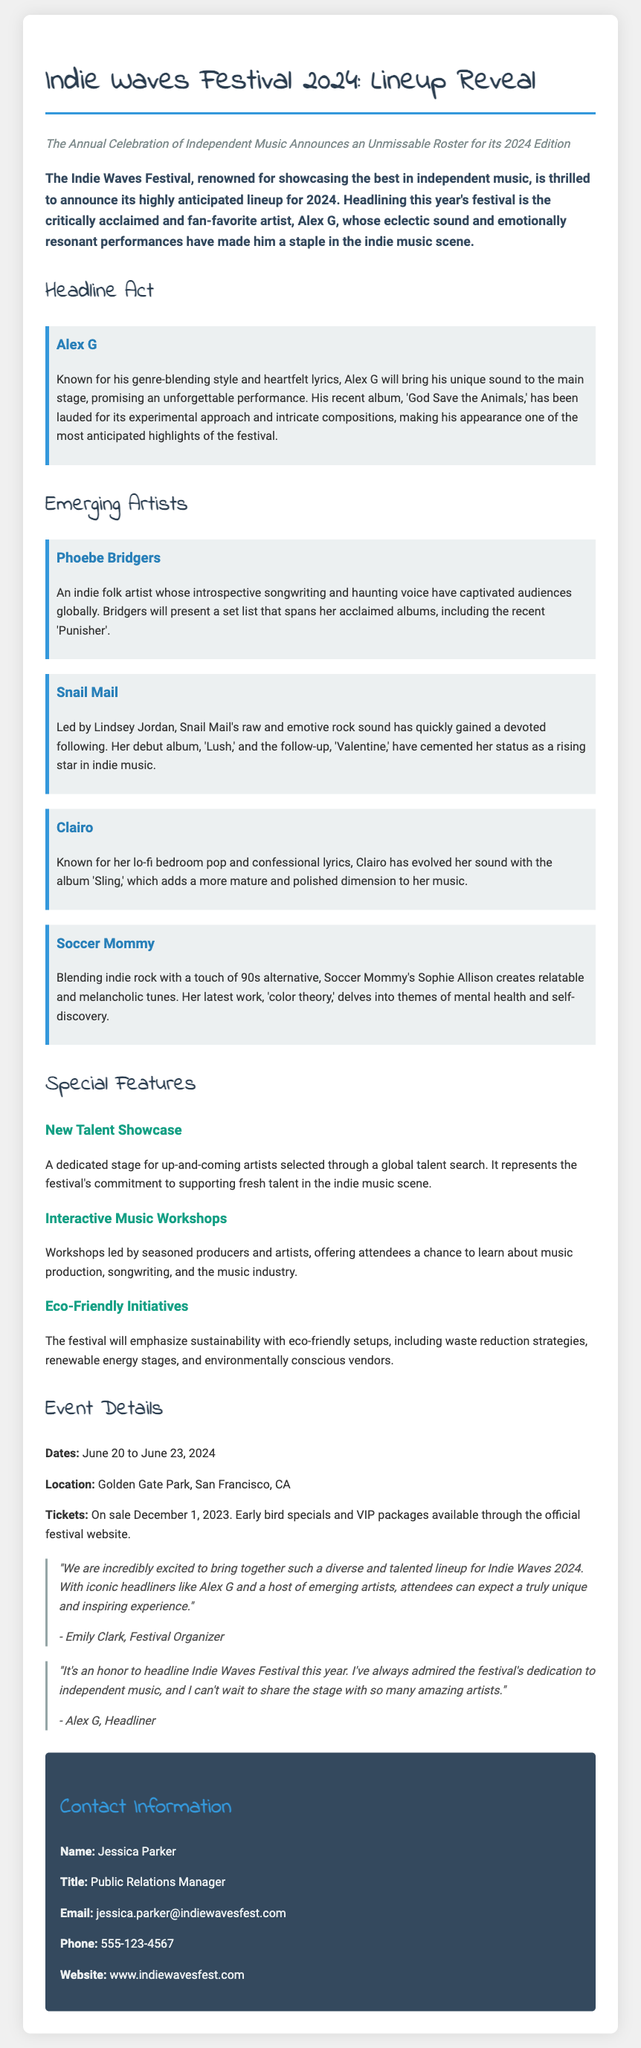What are the festival dates? The festival dates are mentioned in the event details section of the document, which states that it will take place from June 20 to June 23, 2024.
Answer: June 20 to June 23, 2024 Who is the headliner for the festival? The lead section of the press release specifies that Alex G is the headliner for this year's festival.
Answer: Alex G Where is the Indie Waves Festival held? The location is provided in the event details section, which states that it will be held at Golden Gate Park, San Francisco, CA.
Answer: Golden Gate Park, San Francisco, CA What is one of the special features of the festival? The special features of the festival include several aspects such as interactive music workshops, which are mentioned in the special features section of the document.
Answer: Interactive Music Workshops When can tickets be purchased? The document specifies that tickets will be on sale starting December 1, 2023.
Answer: December 1, 2023 What type of artists will be showcased besides the headliner? The document mentions that emerging artists will also be showcased alongside the headliner.
Answer: Emerging Artists What does the New Talent Showcase emphasize? The New Talent Showcase, as described in the special features section, emphasizes the festival's commitment to supporting fresh talent.
Answer: Supporting fresh talent Who is the Public Relations Manager for the festival? The contact information section lists Jessica Parker as the Public Relations Manager for the festival.
Answer: Jessica Parker What is the focus of the eco-friendly initiatives mentioned? The eco-friendly initiatives section highlights an emphasis on sustainability in the festival's operations.
Answer: Sustainability 